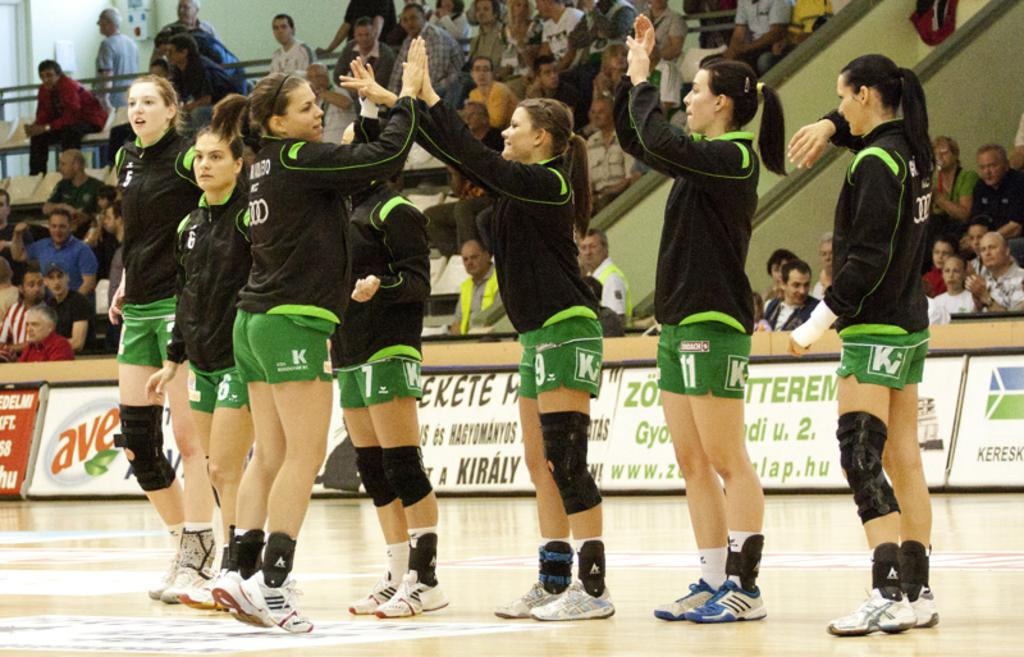<image>
Summarize the visual content of the image. Athletes giving each other high fives while wearing green shorts with a letter K on it. 